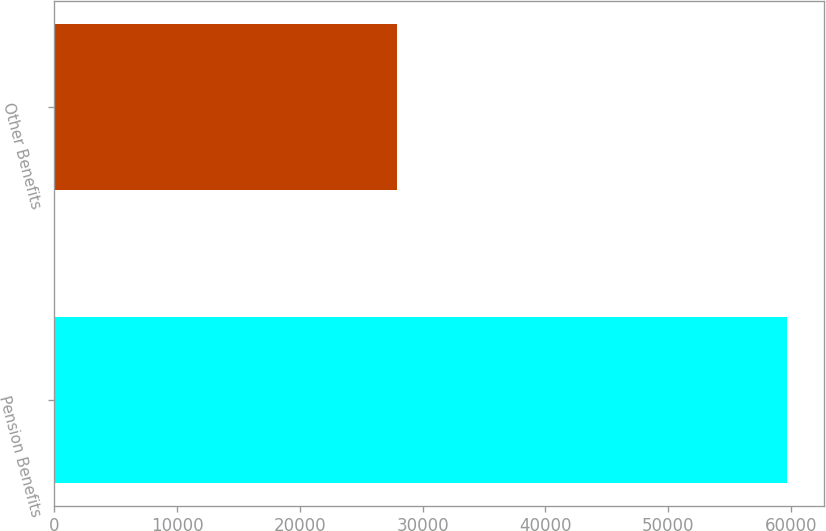<chart> <loc_0><loc_0><loc_500><loc_500><bar_chart><fcel>Pension Benefits<fcel>Other Benefits<nl><fcel>59706<fcel>27880<nl></chart> 